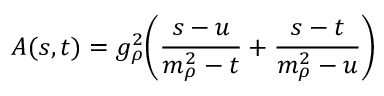Convert formula to latex. <formula><loc_0><loc_0><loc_500><loc_500>A ( s , t ) = g _ { \rho } ^ { 2 } \left ( { \frac { s - u } { m _ { \rho } ^ { 2 } - t } } + { \frac { s - t } { m _ { \rho } ^ { 2 } - u } } \right )</formula> 